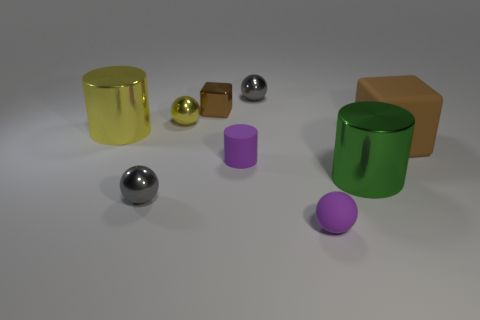What shape is the small gray thing that is in front of the large shiny thing that is on the right side of the yellow shiny thing that is on the right side of the big yellow metal thing?
Keep it short and to the point. Sphere. There is a green shiny thing; does it have the same size as the gray sphere that is behind the large yellow cylinder?
Keep it short and to the point. No. There is a small ball that is to the right of the purple rubber cylinder and behind the yellow shiny cylinder; what is its color?
Your response must be concise. Gray. How many other objects are there of the same shape as the big yellow object?
Make the answer very short. 2. There is a small ball on the left side of the tiny yellow sphere; does it have the same color as the shiny object behind the small brown shiny thing?
Provide a short and direct response. Yes. There is a block that is on the right side of the purple matte cylinder; is its size the same as the gray shiny object that is to the right of the brown metallic cube?
Make the answer very short. No. The brown thing on the right side of the gray sphere on the right side of the small gray metallic thing that is left of the yellow ball is made of what material?
Ensure brevity in your answer.  Rubber. Is the shape of the small brown shiny thing the same as the green thing?
Offer a terse response. No. There is another brown thing that is the same shape as the small brown thing; what is its material?
Offer a terse response. Rubber. What number of things are the same color as the tiny cube?
Give a very brief answer. 1. 